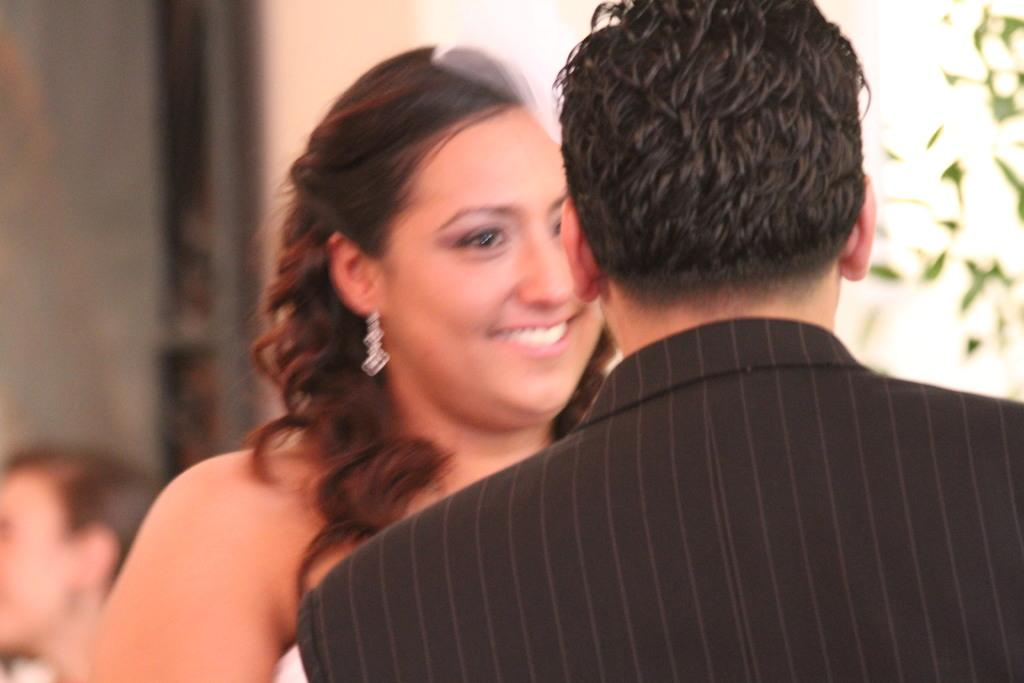Who can be seen in the foreground of the picture? There is a couple standing in the foreground of the picture. What can be observed about the background of the image? The background of the image is blurred. What type of vegetation is present on the right side of the image? There is greenery on the right side of the image. Are there any other people visible in the image? Yes, there is a person on the left side of the image. What type of crook is the person on the left side of the image holding? There is no crook present in the image; the person on the left side of the image is not holding anything. 